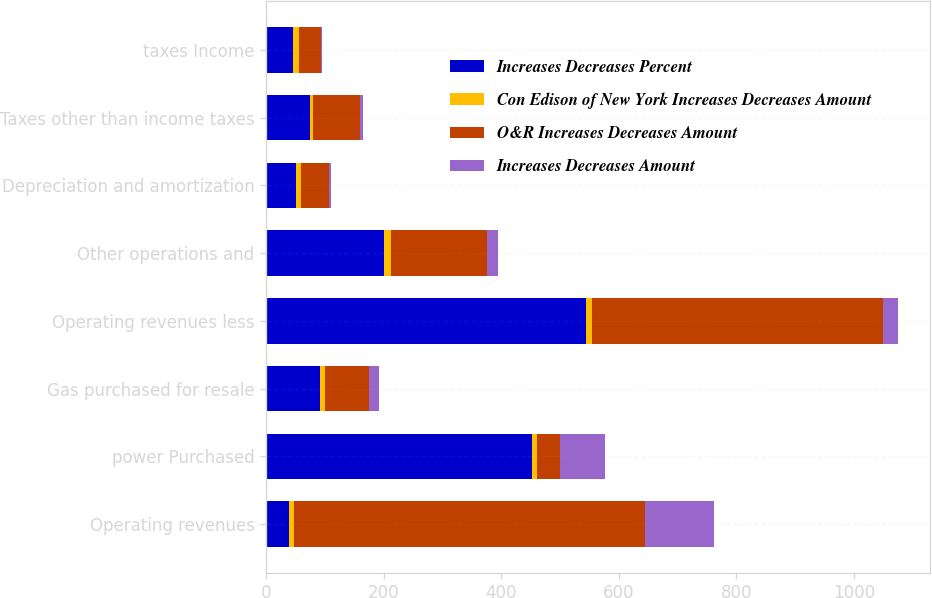Convert chart. <chart><loc_0><loc_0><loc_500><loc_500><stacked_bar_chart><ecel><fcel>Operating revenues<fcel>power Purchased<fcel>Gas purchased for resale<fcel>Operating revenues less<fcel>Other operations and<fcel>Depreciation and amortization<fcel>Taxes other than income taxes<fcel>taxes Income<nl><fcel>Increases Decreases Percent<fcel>38<fcel>452<fcel>91<fcel>544<fcel>201<fcel>50<fcel>74<fcel>45<nl><fcel>Con Edison of New York Increases Decreases Amount<fcel>9.7<fcel>9.1<fcel>8.4<fcel>10.2<fcel>10.7<fcel>8.4<fcel>5.9<fcel>11.1<nl><fcel>O&R Increases Decreases Amount<fcel>597<fcel>38<fcel>76<fcel>496<fcel>164<fcel>48<fcel>80<fcel>37<nl><fcel>Increases Decreases Amount<fcel>118<fcel>77<fcel>16<fcel>25<fcel>18<fcel>3<fcel>5<fcel>1<nl></chart> 